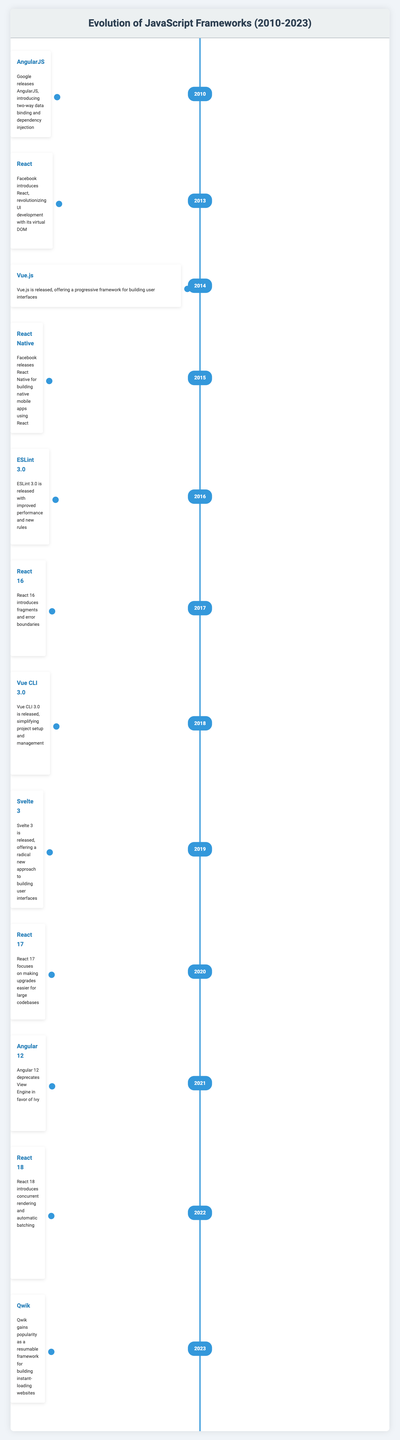What JavaScript framework was released in 2014? Referring to the table, in the year 2014, Vue.js is listed as the framework that was released.
Answer: Vue.js Which frameworks were released in 2013? In 2013, the table shows that React and Ember.js 1.0 were both released.
Answer: React and Ember.js 1.0 What is the earliest framework mentioned in the table? The table indicates that AngularJS and Backbone.js were released in 2010, making it the earliest framework mentioned.
Answer: AngularJS and Backbone.js How many frameworks were introduced after 2018? The table lists the frameworks introduced after 2018 as follows: React 18 in 2022, Astro 1.0 in 2022, Qwik in 2023, and Bun in 2023. This totals four frameworks introduced after 2018.
Answer: Four Is it true that Vue.js was released before React? Looking at the timeline, Vue.js was released in 2014 and React was introduced in 2013, which makes the statement false.
Answer: No Which framework introduced an improvement in rendering performance in 2016? According to the table, Vue.js 2.0 was released in 2016, and it is specifically mentioned to have improved rendering performance.
Answer: Vue.js 2.0 What significant feature was added to React in 2018? The table states that React introduced Hooks in 2018, which allowed state and lifecycle features in functional components.
Answer: Hooks What incremental change did Angular 12 represent compared to previous versions? Angular 12 is noted for deprecating View Engine in favor of Ivy. This indicates a significant change in how Angular structured its rendering engine.
Answer: Deprecating View Engine for Ivy 